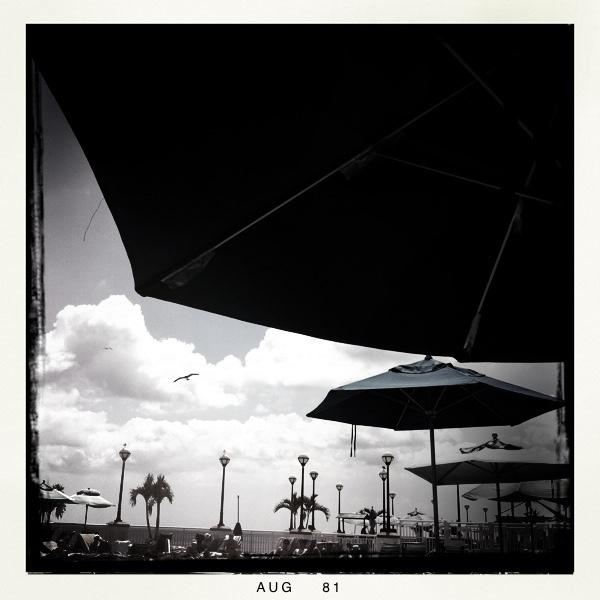Which US state is most likely to contain palm trees like the ones contained in this image?

Choices:
A) florida
B) maine
C) pennsylvania
D) new york florida 